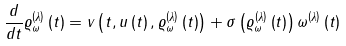Convert formula to latex. <formula><loc_0><loc_0><loc_500><loc_500>\frac { d } { d t } \varrho _ { \omega } ^ { \left ( \lambda \right ) } \left ( t \right ) = v \left ( t , u \left ( t \right ) , \varrho _ { \omega } ^ { \left ( \lambda \right ) } \left ( t \right ) \right ) + \sigma \left ( \varrho _ { \omega } ^ { \left ( \lambda \right ) } \left ( t \right ) \right ) \omega ^ { \left ( \lambda \right ) } \left ( t \right )</formula> 